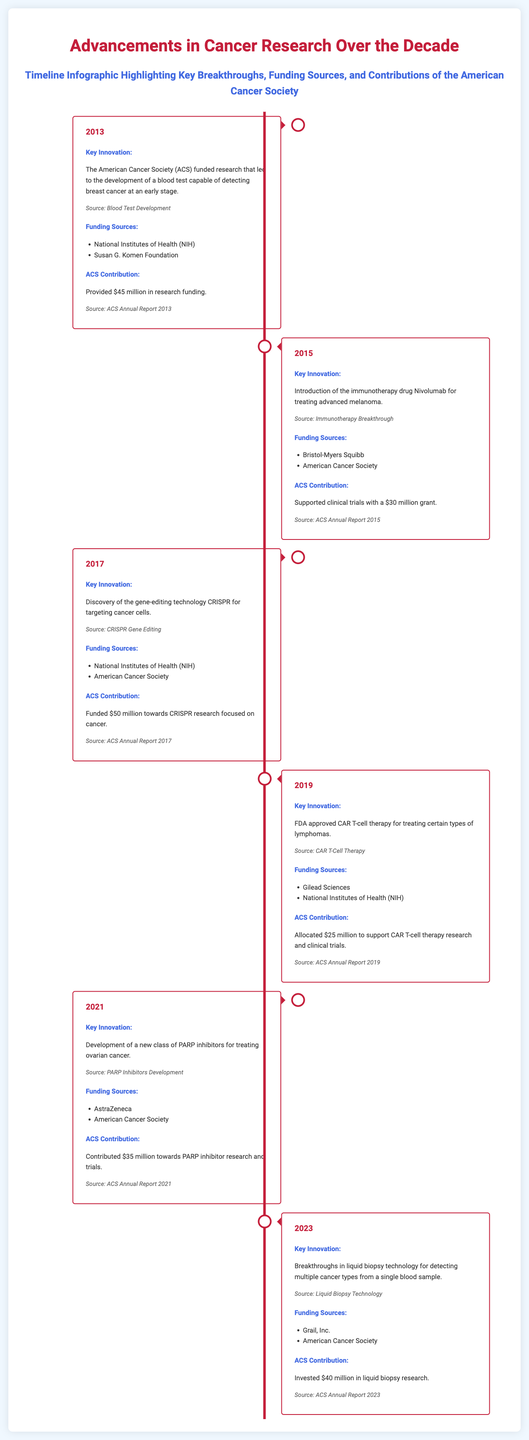What key innovation was funded by ACS in 2013? The document states that the American Cancer Society (ACS) funded research that led to the development of a blood test capable of detecting breast cancer at an early stage in 2013.
Answer: Blood test for breast cancer detection How much did ACS contribute in 2015? The document indicates that ACS supported clinical trials with a $30 million grant in 2015.
Answer: $30 million Which organization funded the development of the gene-editing technology CRISPR in 2017? The document states that both the National Institutes of Health (NIH) and the American Cancer Society funded the discovery of CRISPR in 2017.
Answer: National Institutes of Health (NIH) What was the funding amount provided by ACS for liquid biopsy research in 2023? According to the document, ACS invested $40 million in liquid biopsy research in 2023.
Answer: $40 million What is the main focus of the breakthroughs in 2019? The key innovation highlighted in 2019 was the FDA approval of CAR T-cell therapy for treating certain types of lymphomas.
Answer: FDA approval of CAR T-cell therapy Which year did the introduction of PARP inhibitors occur? The document mentions that the development of a new class of PARP inhibitors for treating ovarian cancer took place in 2021.
Answer: 2021 What breakthrough was achieved in liquid biopsy technology? The document outlines that breakthroughs in liquid biopsy technology allowed for detecting multiple cancer types from a single blood sample.
Answer: Detecting multiple cancer types Which company collaborated with ACS on PARP inhibitors? The document indicates that AstraZeneca collaborated with the American Cancer Society on PARP inhibitor research.
Answer: AstraZeneca How much was allocated by ACS for CAR T-cell therapy research? The document states that ACS allocated $25 million to support CAR T-cell therapy research and clinical trials in 2019.
Answer: $25 million 